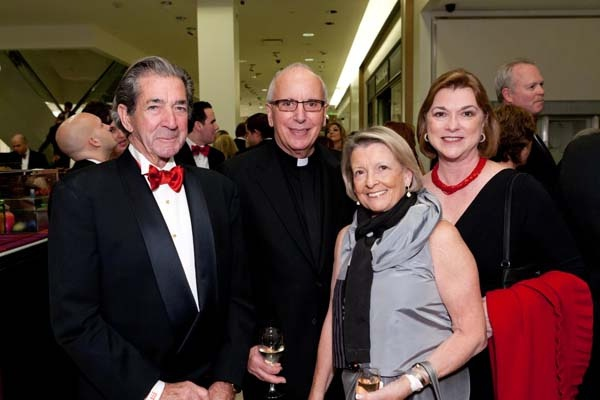Describe the objects in this image and their specific colors. I can see people in darkgreen, black, lightpink, white, and brown tones, people in darkgreen, black, brown, lightpink, and maroon tones, people in darkgreen, darkgray, lightpink, black, and gray tones, people in darkgreen, black, lightpink, brown, and maroon tones, and people in darkgreen, black, maroon, and gray tones in this image. 